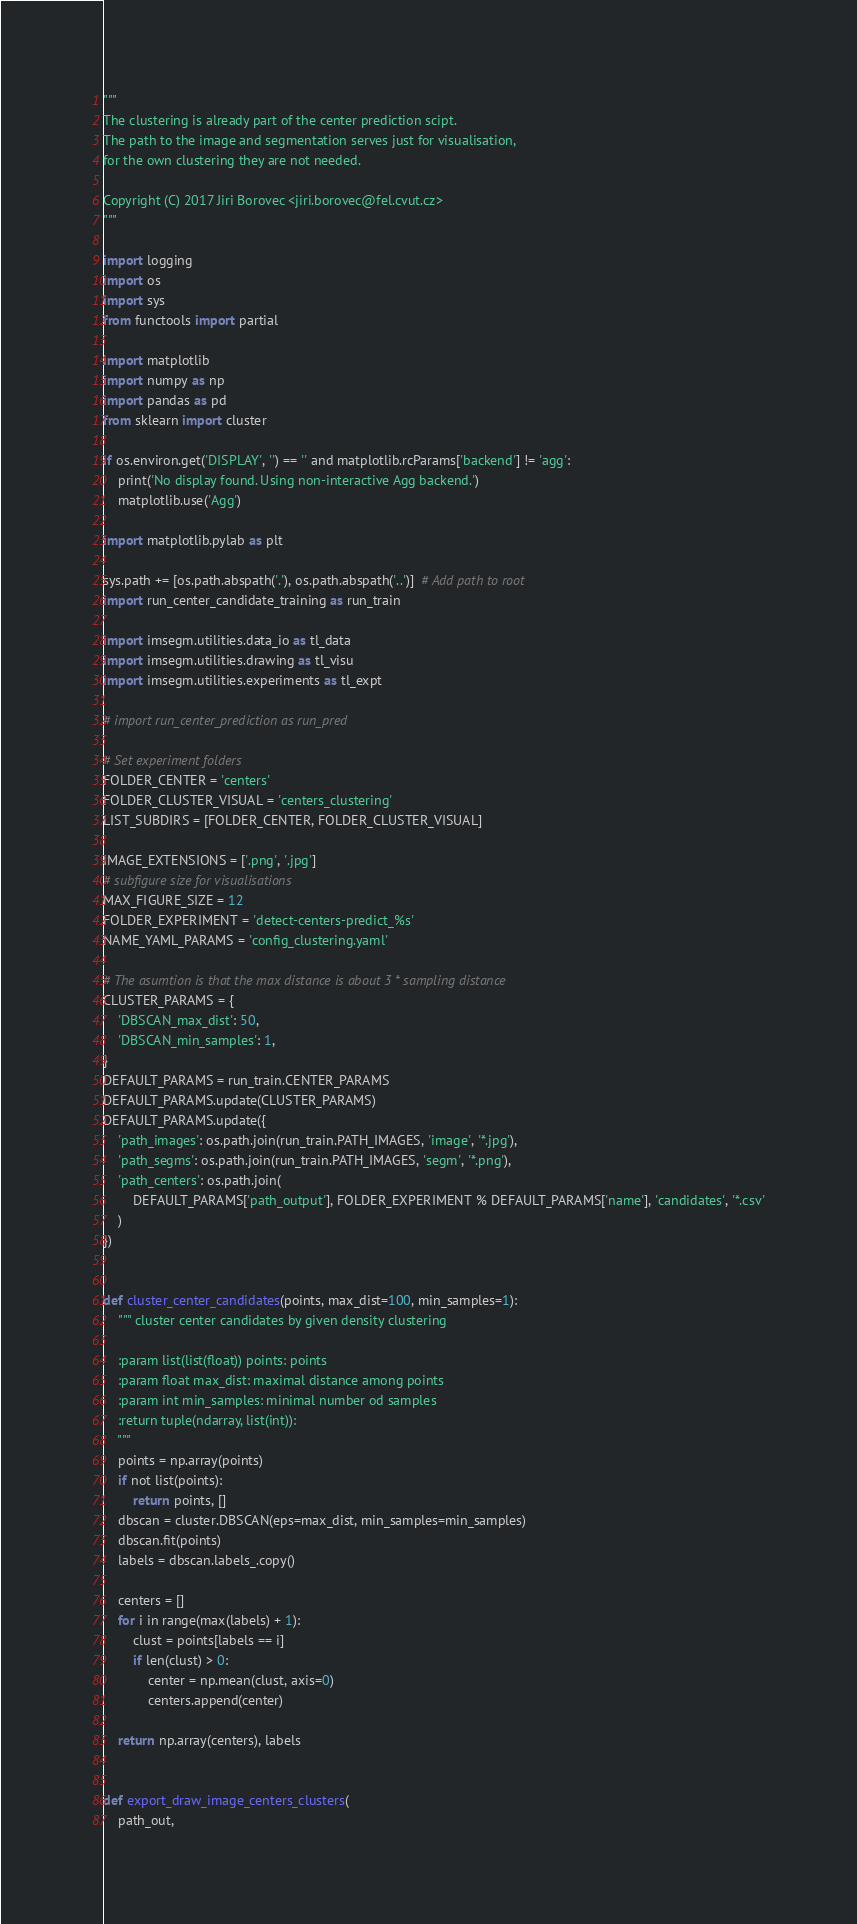<code> <loc_0><loc_0><loc_500><loc_500><_Python_>"""
The clustering is already part of the center prediction scipt.
The path to the image and segmentation serves just for visualisation,
for the own clustering they are not needed.

Copyright (C) 2017 Jiri Borovec <jiri.borovec@fel.cvut.cz>
"""

import logging
import os
import sys
from functools import partial

import matplotlib
import numpy as np
import pandas as pd
from sklearn import cluster

if os.environ.get('DISPLAY', '') == '' and matplotlib.rcParams['backend'] != 'agg':
    print('No display found. Using non-interactive Agg backend.')
    matplotlib.use('Agg')

import matplotlib.pylab as plt

sys.path += [os.path.abspath('.'), os.path.abspath('..')]  # Add path to root
import run_center_candidate_training as run_train

import imsegm.utilities.data_io as tl_data
import imsegm.utilities.drawing as tl_visu
import imsegm.utilities.experiments as tl_expt

# import run_center_prediction as run_pred

# Set experiment folders
FOLDER_CENTER = 'centers'
FOLDER_CLUSTER_VISUAL = 'centers_clustering'
LIST_SUBDIRS = [FOLDER_CENTER, FOLDER_CLUSTER_VISUAL]

IMAGE_EXTENSIONS = ['.png', '.jpg']
# subfigure size for visualisations
MAX_FIGURE_SIZE = 12
FOLDER_EXPERIMENT = 'detect-centers-predict_%s'
NAME_YAML_PARAMS = 'config_clustering.yaml'

# The asumtion is that the max distance is about 3 * sampling distance
CLUSTER_PARAMS = {
    'DBSCAN_max_dist': 50,
    'DBSCAN_min_samples': 1,
}
DEFAULT_PARAMS = run_train.CENTER_PARAMS
DEFAULT_PARAMS.update(CLUSTER_PARAMS)
DEFAULT_PARAMS.update({
    'path_images': os.path.join(run_train.PATH_IMAGES, 'image', '*.jpg'),
    'path_segms': os.path.join(run_train.PATH_IMAGES, 'segm', '*.png'),
    'path_centers': os.path.join(
        DEFAULT_PARAMS['path_output'], FOLDER_EXPERIMENT % DEFAULT_PARAMS['name'], 'candidates', '*.csv'
    )
})


def cluster_center_candidates(points, max_dist=100, min_samples=1):
    """ cluster center candidates by given density clustering

    :param list(list(float)) points: points
    :param float max_dist: maximal distance among points
    :param int min_samples: minimal number od samples
    :return tuple(ndarray, list(int)):
    """
    points = np.array(points)
    if not list(points):
        return points, []
    dbscan = cluster.DBSCAN(eps=max_dist, min_samples=min_samples)
    dbscan.fit(points)
    labels = dbscan.labels_.copy()

    centers = []
    for i in range(max(labels) + 1):
        clust = points[labels == i]
        if len(clust) > 0:
            center = np.mean(clust, axis=0)
            centers.append(center)

    return np.array(centers), labels


def export_draw_image_centers_clusters(
    path_out,</code> 